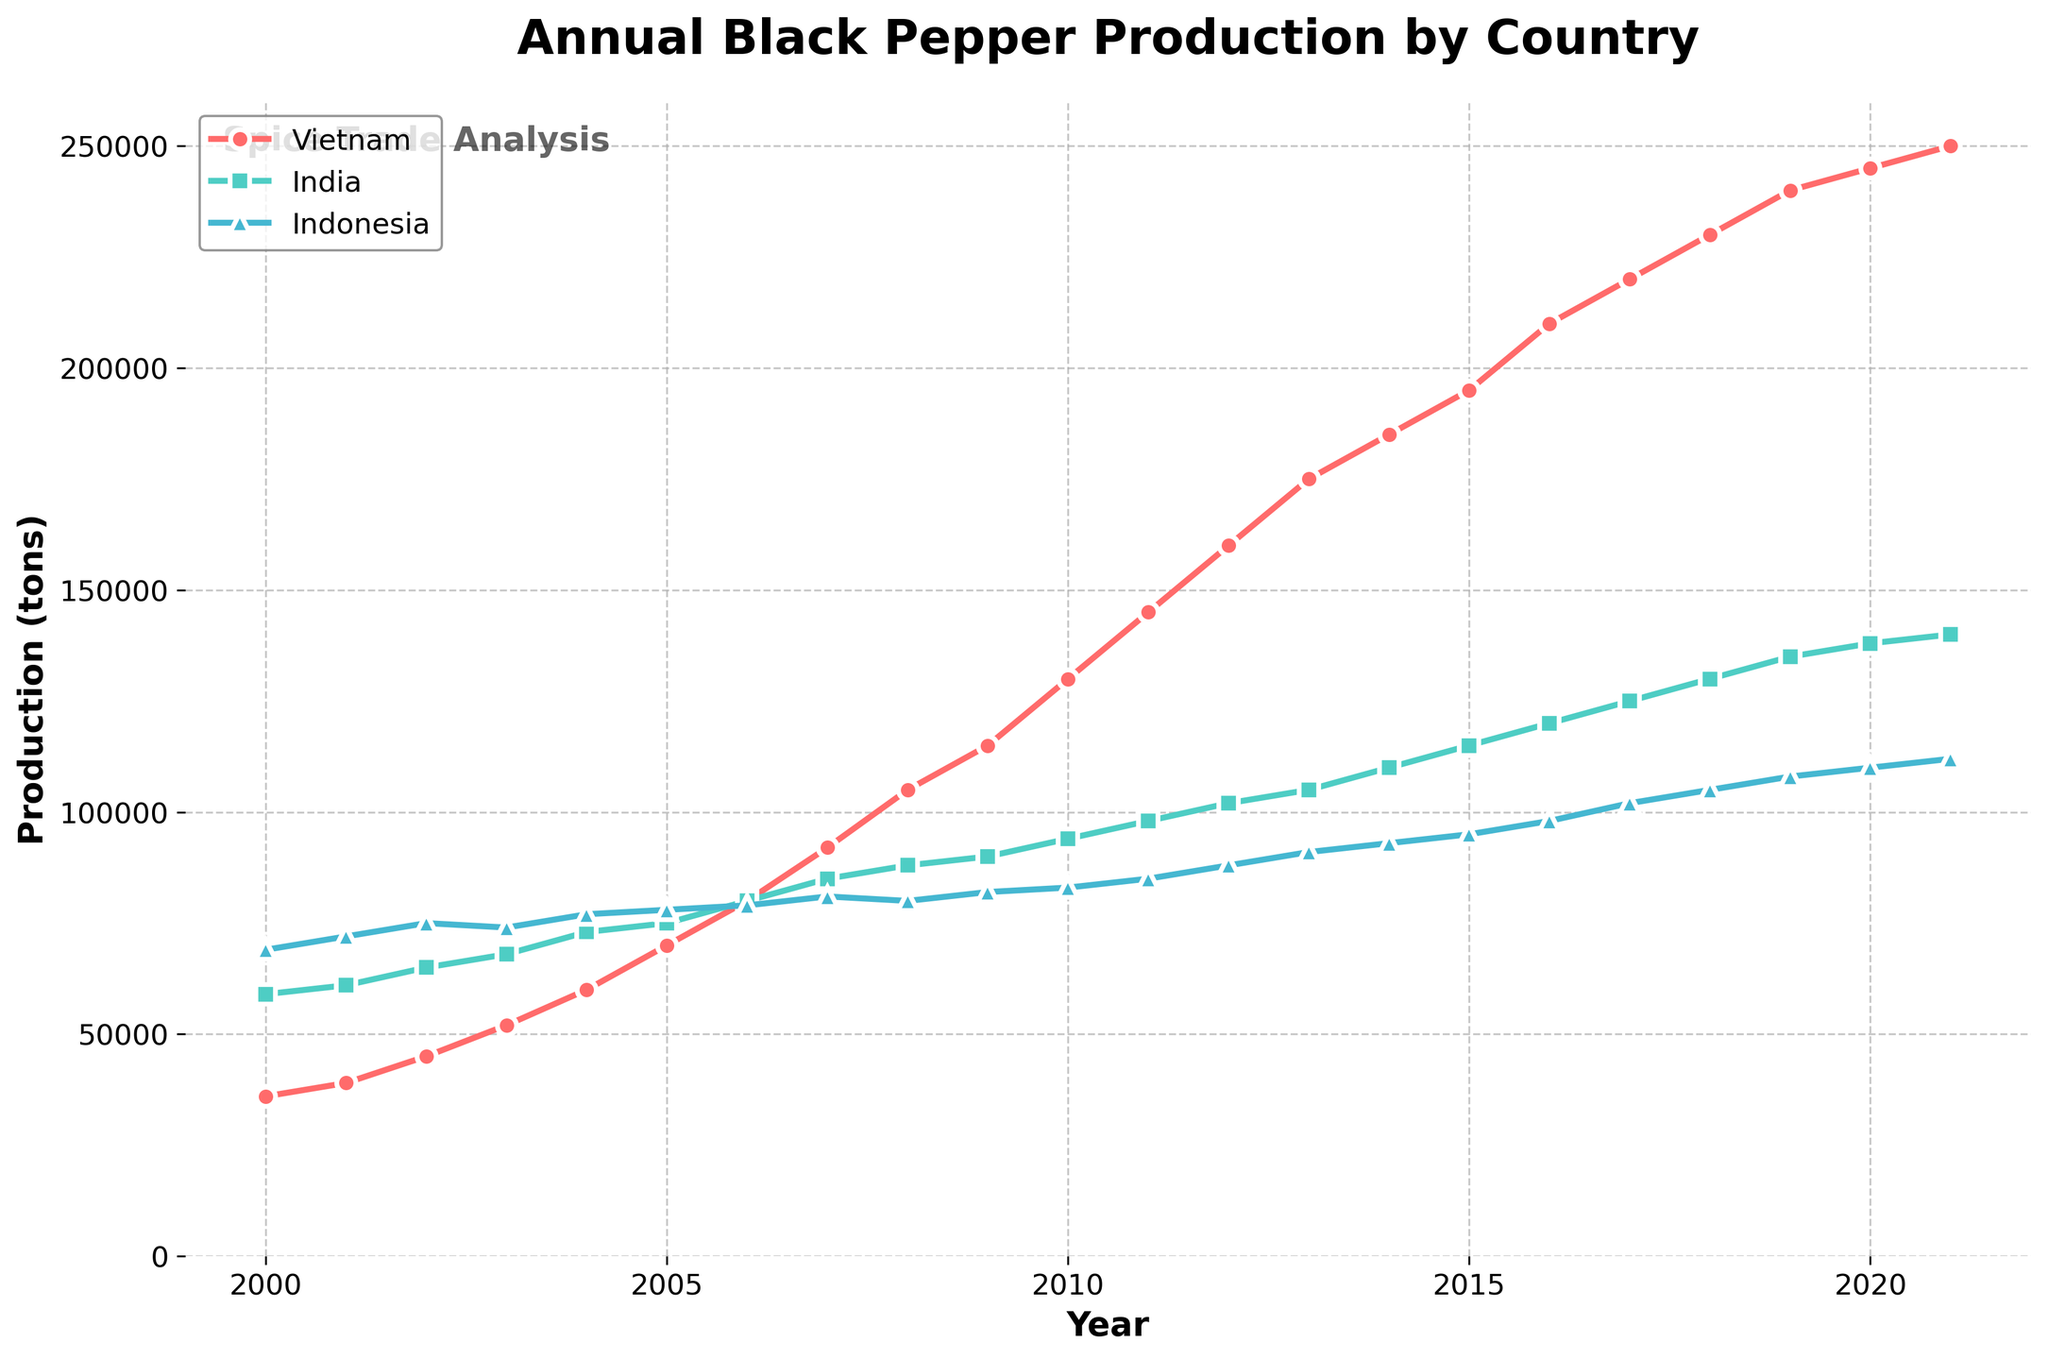What is the overall trend of black pepper production in Vietnam from 2000 to 2021? Starting from 36,000 tons in 2000, the production in Vietnam consistently increased each year, reaching 250,000 tons by 2021. The line shows a steady upward trajectory.
Answer: Steady increase Which country had the highest black pepper production in 2021? In 2021, the production values for Vietnam, India, and Indonesia were 250,000 tons, 140,000 tons, and 112,000 tons respectively. The highest value is for Vietnam.
Answer: Vietnam How did the black pepper production in India change from 2000 to 2006? The black pepper production in India increased from 59,000 tons in 2000 to 80,000 tons in 2006. This change shows a steady rise over these years.
Answer: Increased In what years did Indonesia’s black pepper production not increase compared to the previous year? Indonesia’s production did not increase in 2003 (decreased from 75,000 to 74,000), 2008 (decreased from 81,000 to 80,000), and 2020 (remained 110,000 from 2019).
Answer: 2003, 2008, 2020 What year did Vietnam’s black pepper production surpass 100,000 tons? Referring to the chart, Vietnam’s production surpasses 100,000 tons between 2007 and 2008. In 2008, it reached 105,000 tons.
Answer: 2008 If the total black pepper production in 2010 is combined for all three countries, what would be the total? In 2010, the productions were 130,000 tons (Vietnam), 94,000 tons (India), and 83,000 tons (Indonesia). The total is 130,000 + 94,000 + 83,000 = 307,000 tons.
Answer: 307,000 tons Which country shows the most significant increase in production from 2000 to 2021? Vietnam’s production increased from 36,000 tons in 2000 to 250,000 tons in 2021. India went from 59,000 to 140,000 tons, and Indonesia from 69,000 to 112,000 tons. Vietnam shows the most significant increase.
Answer: Vietnam How does the increase in black pepper production from 2005 to 2015 compare between Vietnam and India? In Vietnam, production increased from 70,000 tons in 2005 to 195,000 tons in 2015, an increase of 125,000 tons. In India, production rose from 75,000 tons to 115,000 tons, an increase of 40,000 tons. Vietnam had a larger increase.
Answer: Vietnam had a larger increase How does the visual representation of India’s production differ from Vietnam's? India's production line is depicted in a green color with square markers, whereas Vietnam's production line is in a red color with circular markers. Visually, India’s line is consistently lower than Vietnam's and shows a more gradual increase.
Answer: Different colors and markers, steeper increase for Vietnam In what year did India and Indonesia’s production both exceed 100,000 tons? India’s production first exceeded 100,000 tons in 2012, while Indonesia reached 100,000 tons in 2017.
Answer: No single year, different years 